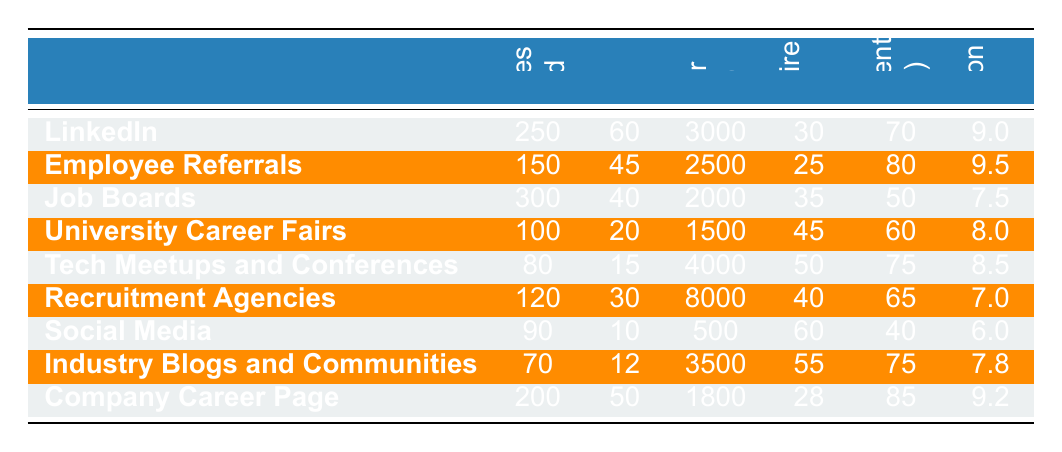What is the sourcing channel with the highest number of quality hires? By looking at the "Quality Hires" column, we see that "LinkedIn" has the highest number of quality hires at 60.
Answer: LinkedIn What is the cost per hire for employee referrals? The table shows that the "Cost Per Hire" for "Employee Referrals" is 2500.
Answer: 2500 Which sourcing channel has the lowest engagement rate? The "Engagement Rate" for "Social Media" is the lowest at 40%.
Answer: Social Media What was the average time to hire across all sourcing channels? To find the average, we sum the "Time to Hire" values: 30 + 25 + 35 + 45 + 50 + 40 + 60 + 55 + 28 = 418, and divide by the number of channels (9). So, 418 / 9 = 46.44 days.
Answer: Approximately 46.44 days Did "Tech Meetups and Conferences" yield more candidates than "University Career Fairs"? The table shows that "Tech Meetups and Conferences" identified 80 candidates and "University Career Fairs" identified 100; therefore, "University Career Fairs" yielded more candidates.
Answer: Yes What was the candidate satisfaction score for job boards? Referring to the "Candidate Satisfaction Score" column, "Job Boards" has a score of 7.5.
Answer: 7.5 What is the total number of quality hires for "LinkedIn" and "Company Career Page"? To find this total, we add the quality hires: 60 (LinkedIn) + 50 (Company Career Page) = 110.
Answer: 110 Which sourcing channel was the most cost-effective based on the cost per hire? We compare the cost per hire of each channel; "Social Media" has the lowest cost per hire at 500, making it the most cost-effective.
Answer: Social Media If we consider the top three sourcing channels for engagement rate, what is their average candidate satisfaction score? The top three channels based on engagement rate are "Company Career Page" (85%), "Employee Referrals" (80%), and "Tech Meetups and Conferences" (75%). The average of their candidate satisfaction scores (9.2, 9.5, and 8.5) is (9.2 + 9.5 + 8.5) / 3 = 9.07.
Answer: Approximately 9.07 How many candidates were identified through "Recruitment Agencies"? From the table, "Recruitment Agencies" identified 120 candidates.
Answer: 120 Which sourcing channel had the longest time to hire? By examining the "Time to Hire" column, we see that "Social Media" took the longest at 60 days.
Answer: Social Media 